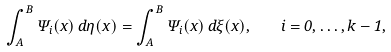<formula> <loc_0><loc_0><loc_500><loc_500>\int ^ { B } _ { A } \Psi _ { i } ( x ) \, d \eta ( x ) = \int ^ { B } _ { A } \Psi _ { i } ( x ) \, d \xi ( x ) , \quad i = 0 , \dots , k - 1 ,</formula> 